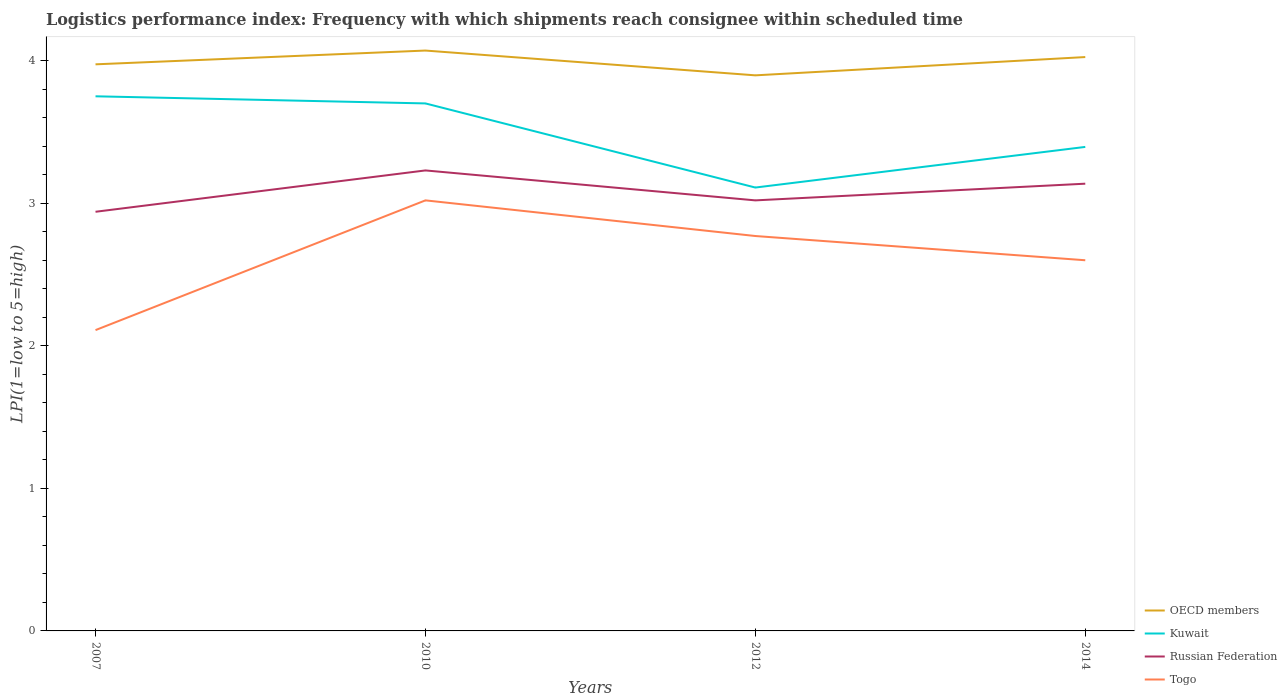How many different coloured lines are there?
Provide a short and direct response. 4. Across all years, what is the maximum logistics performance index in Russian Federation?
Offer a terse response. 2.94. What is the total logistics performance index in Togo in the graph?
Provide a short and direct response. -0.49. What is the difference between the highest and the second highest logistics performance index in OECD members?
Your answer should be very brief. 0.17. Is the logistics performance index in Togo strictly greater than the logistics performance index in Kuwait over the years?
Keep it short and to the point. Yes. How many lines are there?
Provide a succinct answer. 4. Where does the legend appear in the graph?
Offer a terse response. Bottom right. How many legend labels are there?
Give a very brief answer. 4. What is the title of the graph?
Your answer should be compact. Logistics performance index: Frequency with which shipments reach consignee within scheduled time. Does "Bhutan" appear as one of the legend labels in the graph?
Provide a short and direct response. No. What is the label or title of the X-axis?
Give a very brief answer. Years. What is the label or title of the Y-axis?
Offer a very short reply. LPI(1=low to 5=high). What is the LPI(1=low to 5=high) in OECD members in 2007?
Make the answer very short. 3.97. What is the LPI(1=low to 5=high) of Kuwait in 2007?
Offer a terse response. 3.75. What is the LPI(1=low to 5=high) in Russian Federation in 2007?
Keep it short and to the point. 2.94. What is the LPI(1=low to 5=high) in Togo in 2007?
Ensure brevity in your answer.  2.11. What is the LPI(1=low to 5=high) in OECD members in 2010?
Your answer should be very brief. 4.07. What is the LPI(1=low to 5=high) of Russian Federation in 2010?
Provide a short and direct response. 3.23. What is the LPI(1=low to 5=high) of Togo in 2010?
Ensure brevity in your answer.  3.02. What is the LPI(1=low to 5=high) of OECD members in 2012?
Keep it short and to the point. 3.9. What is the LPI(1=low to 5=high) in Kuwait in 2012?
Make the answer very short. 3.11. What is the LPI(1=low to 5=high) of Russian Federation in 2012?
Provide a short and direct response. 3.02. What is the LPI(1=low to 5=high) in Togo in 2012?
Offer a very short reply. 2.77. What is the LPI(1=low to 5=high) of OECD members in 2014?
Your answer should be compact. 4.03. What is the LPI(1=low to 5=high) in Kuwait in 2014?
Offer a terse response. 3.39. What is the LPI(1=low to 5=high) in Russian Federation in 2014?
Your answer should be very brief. 3.14. What is the LPI(1=low to 5=high) in Togo in 2014?
Ensure brevity in your answer.  2.6. Across all years, what is the maximum LPI(1=low to 5=high) in OECD members?
Offer a terse response. 4.07. Across all years, what is the maximum LPI(1=low to 5=high) of Kuwait?
Your answer should be compact. 3.75. Across all years, what is the maximum LPI(1=low to 5=high) of Russian Federation?
Your response must be concise. 3.23. Across all years, what is the maximum LPI(1=low to 5=high) in Togo?
Your answer should be very brief. 3.02. Across all years, what is the minimum LPI(1=low to 5=high) of OECD members?
Your answer should be compact. 3.9. Across all years, what is the minimum LPI(1=low to 5=high) in Kuwait?
Offer a very short reply. 3.11. Across all years, what is the minimum LPI(1=low to 5=high) of Russian Federation?
Provide a short and direct response. 2.94. Across all years, what is the minimum LPI(1=low to 5=high) of Togo?
Make the answer very short. 2.11. What is the total LPI(1=low to 5=high) in OECD members in the graph?
Your answer should be very brief. 15.97. What is the total LPI(1=low to 5=high) of Kuwait in the graph?
Your response must be concise. 13.96. What is the total LPI(1=low to 5=high) in Russian Federation in the graph?
Provide a short and direct response. 12.33. What is the difference between the LPI(1=low to 5=high) in OECD members in 2007 and that in 2010?
Ensure brevity in your answer.  -0.1. What is the difference between the LPI(1=low to 5=high) of Kuwait in 2007 and that in 2010?
Provide a short and direct response. 0.05. What is the difference between the LPI(1=low to 5=high) of Russian Federation in 2007 and that in 2010?
Your response must be concise. -0.29. What is the difference between the LPI(1=low to 5=high) in Togo in 2007 and that in 2010?
Your answer should be compact. -0.91. What is the difference between the LPI(1=low to 5=high) of OECD members in 2007 and that in 2012?
Keep it short and to the point. 0.08. What is the difference between the LPI(1=low to 5=high) of Kuwait in 2007 and that in 2012?
Offer a very short reply. 0.64. What is the difference between the LPI(1=low to 5=high) of Russian Federation in 2007 and that in 2012?
Your response must be concise. -0.08. What is the difference between the LPI(1=low to 5=high) of Togo in 2007 and that in 2012?
Offer a very short reply. -0.66. What is the difference between the LPI(1=low to 5=high) of OECD members in 2007 and that in 2014?
Offer a terse response. -0.05. What is the difference between the LPI(1=low to 5=high) of Kuwait in 2007 and that in 2014?
Keep it short and to the point. 0.35. What is the difference between the LPI(1=low to 5=high) of Russian Federation in 2007 and that in 2014?
Your answer should be very brief. -0.2. What is the difference between the LPI(1=low to 5=high) of Togo in 2007 and that in 2014?
Provide a short and direct response. -0.49. What is the difference between the LPI(1=low to 5=high) in OECD members in 2010 and that in 2012?
Your answer should be compact. 0.17. What is the difference between the LPI(1=low to 5=high) of Kuwait in 2010 and that in 2012?
Give a very brief answer. 0.59. What is the difference between the LPI(1=low to 5=high) in Russian Federation in 2010 and that in 2012?
Your answer should be compact. 0.21. What is the difference between the LPI(1=low to 5=high) of Togo in 2010 and that in 2012?
Offer a terse response. 0.25. What is the difference between the LPI(1=low to 5=high) of OECD members in 2010 and that in 2014?
Offer a terse response. 0.05. What is the difference between the LPI(1=low to 5=high) of Kuwait in 2010 and that in 2014?
Your answer should be compact. 0.3. What is the difference between the LPI(1=low to 5=high) in Russian Federation in 2010 and that in 2014?
Your answer should be compact. 0.09. What is the difference between the LPI(1=low to 5=high) of Togo in 2010 and that in 2014?
Give a very brief answer. 0.42. What is the difference between the LPI(1=low to 5=high) of OECD members in 2012 and that in 2014?
Your answer should be very brief. -0.13. What is the difference between the LPI(1=low to 5=high) of Kuwait in 2012 and that in 2014?
Make the answer very short. -0.28. What is the difference between the LPI(1=low to 5=high) in Russian Federation in 2012 and that in 2014?
Give a very brief answer. -0.12. What is the difference between the LPI(1=low to 5=high) of Togo in 2012 and that in 2014?
Provide a succinct answer. 0.17. What is the difference between the LPI(1=low to 5=high) of OECD members in 2007 and the LPI(1=low to 5=high) of Kuwait in 2010?
Give a very brief answer. 0.27. What is the difference between the LPI(1=low to 5=high) of OECD members in 2007 and the LPI(1=low to 5=high) of Russian Federation in 2010?
Offer a terse response. 0.74. What is the difference between the LPI(1=low to 5=high) of OECD members in 2007 and the LPI(1=low to 5=high) of Togo in 2010?
Your answer should be very brief. 0.95. What is the difference between the LPI(1=low to 5=high) of Kuwait in 2007 and the LPI(1=low to 5=high) of Russian Federation in 2010?
Ensure brevity in your answer.  0.52. What is the difference between the LPI(1=low to 5=high) in Kuwait in 2007 and the LPI(1=low to 5=high) in Togo in 2010?
Your response must be concise. 0.73. What is the difference between the LPI(1=low to 5=high) of Russian Federation in 2007 and the LPI(1=low to 5=high) of Togo in 2010?
Your answer should be very brief. -0.08. What is the difference between the LPI(1=low to 5=high) of OECD members in 2007 and the LPI(1=low to 5=high) of Kuwait in 2012?
Offer a very short reply. 0.86. What is the difference between the LPI(1=low to 5=high) in OECD members in 2007 and the LPI(1=low to 5=high) in Russian Federation in 2012?
Give a very brief answer. 0.95. What is the difference between the LPI(1=low to 5=high) of OECD members in 2007 and the LPI(1=low to 5=high) of Togo in 2012?
Offer a very short reply. 1.2. What is the difference between the LPI(1=low to 5=high) of Kuwait in 2007 and the LPI(1=low to 5=high) of Russian Federation in 2012?
Offer a terse response. 0.73. What is the difference between the LPI(1=low to 5=high) of Kuwait in 2007 and the LPI(1=low to 5=high) of Togo in 2012?
Provide a short and direct response. 0.98. What is the difference between the LPI(1=low to 5=high) of Russian Federation in 2007 and the LPI(1=low to 5=high) of Togo in 2012?
Your response must be concise. 0.17. What is the difference between the LPI(1=low to 5=high) of OECD members in 2007 and the LPI(1=low to 5=high) of Kuwait in 2014?
Your response must be concise. 0.58. What is the difference between the LPI(1=low to 5=high) of OECD members in 2007 and the LPI(1=low to 5=high) of Russian Federation in 2014?
Your answer should be very brief. 0.84. What is the difference between the LPI(1=low to 5=high) of OECD members in 2007 and the LPI(1=low to 5=high) of Togo in 2014?
Provide a succinct answer. 1.37. What is the difference between the LPI(1=low to 5=high) of Kuwait in 2007 and the LPI(1=low to 5=high) of Russian Federation in 2014?
Ensure brevity in your answer.  0.61. What is the difference between the LPI(1=low to 5=high) in Kuwait in 2007 and the LPI(1=low to 5=high) in Togo in 2014?
Offer a terse response. 1.15. What is the difference between the LPI(1=low to 5=high) in Russian Federation in 2007 and the LPI(1=low to 5=high) in Togo in 2014?
Provide a succinct answer. 0.34. What is the difference between the LPI(1=low to 5=high) in OECD members in 2010 and the LPI(1=low to 5=high) in Kuwait in 2012?
Your answer should be very brief. 0.96. What is the difference between the LPI(1=low to 5=high) in OECD members in 2010 and the LPI(1=low to 5=high) in Russian Federation in 2012?
Your answer should be very brief. 1.05. What is the difference between the LPI(1=low to 5=high) in OECD members in 2010 and the LPI(1=low to 5=high) in Togo in 2012?
Your response must be concise. 1.3. What is the difference between the LPI(1=low to 5=high) of Kuwait in 2010 and the LPI(1=low to 5=high) of Russian Federation in 2012?
Offer a very short reply. 0.68. What is the difference between the LPI(1=low to 5=high) in Russian Federation in 2010 and the LPI(1=low to 5=high) in Togo in 2012?
Keep it short and to the point. 0.46. What is the difference between the LPI(1=low to 5=high) in OECD members in 2010 and the LPI(1=low to 5=high) in Kuwait in 2014?
Provide a succinct answer. 0.68. What is the difference between the LPI(1=low to 5=high) of OECD members in 2010 and the LPI(1=low to 5=high) of Russian Federation in 2014?
Offer a terse response. 0.93. What is the difference between the LPI(1=low to 5=high) in OECD members in 2010 and the LPI(1=low to 5=high) in Togo in 2014?
Offer a terse response. 1.47. What is the difference between the LPI(1=low to 5=high) in Kuwait in 2010 and the LPI(1=low to 5=high) in Russian Federation in 2014?
Ensure brevity in your answer.  0.56. What is the difference between the LPI(1=low to 5=high) of Russian Federation in 2010 and the LPI(1=low to 5=high) of Togo in 2014?
Ensure brevity in your answer.  0.63. What is the difference between the LPI(1=low to 5=high) of OECD members in 2012 and the LPI(1=low to 5=high) of Kuwait in 2014?
Give a very brief answer. 0.5. What is the difference between the LPI(1=low to 5=high) of OECD members in 2012 and the LPI(1=low to 5=high) of Russian Federation in 2014?
Offer a terse response. 0.76. What is the difference between the LPI(1=low to 5=high) in OECD members in 2012 and the LPI(1=low to 5=high) in Togo in 2014?
Give a very brief answer. 1.3. What is the difference between the LPI(1=low to 5=high) in Kuwait in 2012 and the LPI(1=low to 5=high) in Russian Federation in 2014?
Your response must be concise. -0.03. What is the difference between the LPI(1=low to 5=high) of Kuwait in 2012 and the LPI(1=low to 5=high) of Togo in 2014?
Make the answer very short. 0.51. What is the difference between the LPI(1=low to 5=high) in Russian Federation in 2012 and the LPI(1=low to 5=high) in Togo in 2014?
Your answer should be compact. 0.42. What is the average LPI(1=low to 5=high) in OECD members per year?
Your response must be concise. 3.99. What is the average LPI(1=low to 5=high) in Kuwait per year?
Your response must be concise. 3.49. What is the average LPI(1=low to 5=high) in Russian Federation per year?
Provide a short and direct response. 3.08. What is the average LPI(1=low to 5=high) in Togo per year?
Ensure brevity in your answer.  2.62. In the year 2007, what is the difference between the LPI(1=low to 5=high) in OECD members and LPI(1=low to 5=high) in Kuwait?
Provide a succinct answer. 0.22. In the year 2007, what is the difference between the LPI(1=low to 5=high) in OECD members and LPI(1=low to 5=high) in Russian Federation?
Your response must be concise. 1.03. In the year 2007, what is the difference between the LPI(1=low to 5=high) in OECD members and LPI(1=low to 5=high) in Togo?
Ensure brevity in your answer.  1.86. In the year 2007, what is the difference between the LPI(1=low to 5=high) of Kuwait and LPI(1=low to 5=high) of Russian Federation?
Provide a succinct answer. 0.81. In the year 2007, what is the difference between the LPI(1=low to 5=high) of Kuwait and LPI(1=low to 5=high) of Togo?
Provide a short and direct response. 1.64. In the year 2007, what is the difference between the LPI(1=low to 5=high) of Russian Federation and LPI(1=low to 5=high) of Togo?
Give a very brief answer. 0.83. In the year 2010, what is the difference between the LPI(1=low to 5=high) in OECD members and LPI(1=low to 5=high) in Kuwait?
Make the answer very short. 0.37. In the year 2010, what is the difference between the LPI(1=low to 5=high) in OECD members and LPI(1=low to 5=high) in Russian Federation?
Keep it short and to the point. 0.84. In the year 2010, what is the difference between the LPI(1=low to 5=high) in OECD members and LPI(1=low to 5=high) in Togo?
Your answer should be compact. 1.05. In the year 2010, what is the difference between the LPI(1=low to 5=high) of Kuwait and LPI(1=low to 5=high) of Russian Federation?
Give a very brief answer. 0.47. In the year 2010, what is the difference between the LPI(1=low to 5=high) of Kuwait and LPI(1=low to 5=high) of Togo?
Provide a short and direct response. 0.68. In the year 2010, what is the difference between the LPI(1=low to 5=high) of Russian Federation and LPI(1=low to 5=high) of Togo?
Your answer should be compact. 0.21. In the year 2012, what is the difference between the LPI(1=low to 5=high) in OECD members and LPI(1=low to 5=high) in Kuwait?
Make the answer very short. 0.79. In the year 2012, what is the difference between the LPI(1=low to 5=high) of OECD members and LPI(1=low to 5=high) of Russian Federation?
Give a very brief answer. 0.88. In the year 2012, what is the difference between the LPI(1=low to 5=high) in OECD members and LPI(1=low to 5=high) in Togo?
Your answer should be compact. 1.13. In the year 2012, what is the difference between the LPI(1=low to 5=high) in Kuwait and LPI(1=low to 5=high) in Russian Federation?
Your answer should be compact. 0.09. In the year 2012, what is the difference between the LPI(1=low to 5=high) of Kuwait and LPI(1=low to 5=high) of Togo?
Give a very brief answer. 0.34. In the year 2014, what is the difference between the LPI(1=low to 5=high) in OECD members and LPI(1=low to 5=high) in Kuwait?
Ensure brevity in your answer.  0.63. In the year 2014, what is the difference between the LPI(1=low to 5=high) in OECD members and LPI(1=low to 5=high) in Russian Federation?
Your answer should be compact. 0.89. In the year 2014, what is the difference between the LPI(1=low to 5=high) in OECD members and LPI(1=low to 5=high) in Togo?
Your answer should be compact. 1.43. In the year 2014, what is the difference between the LPI(1=low to 5=high) of Kuwait and LPI(1=low to 5=high) of Russian Federation?
Offer a very short reply. 0.26. In the year 2014, what is the difference between the LPI(1=low to 5=high) in Kuwait and LPI(1=low to 5=high) in Togo?
Your response must be concise. 0.8. In the year 2014, what is the difference between the LPI(1=low to 5=high) in Russian Federation and LPI(1=low to 5=high) in Togo?
Ensure brevity in your answer.  0.54. What is the ratio of the LPI(1=low to 5=high) in OECD members in 2007 to that in 2010?
Offer a terse response. 0.98. What is the ratio of the LPI(1=low to 5=high) in Kuwait in 2007 to that in 2010?
Provide a succinct answer. 1.01. What is the ratio of the LPI(1=low to 5=high) of Russian Federation in 2007 to that in 2010?
Provide a short and direct response. 0.91. What is the ratio of the LPI(1=low to 5=high) of Togo in 2007 to that in 2010?
Provide a short and direct response. 0.7. What is the ratio of the LPI(1=low to 5=high) of OECD members in 2007 to that in 2012?
Offer a terse response. 1.02. What is the ratio of the LPI(1=low to 5=high) of Kuwait in 2007 to that in 2012?
Offer a very short reply. 1.21. What is the ratio of the LPI(1=low to 5=high) of Russian Federation in 2007 to that in 2012?
Keep it short and to the point. 0.97. What is the ratio of the LPI(1=low to 5=high) in Togo in 2007 to that in 2012?
Provide a succinct answer. 0.76. What is the ratio of the LPI(1=low to 5=high) in OECD members in 2007 to that in 2014?
Offer a very short reply. 0.99. What is the ratio of the LPI(1=low to 5=high) of Kuwait in 2007 to that in 2014?
Offer a very short reply. 1.1. What is the ratio of the LPI(1=low to 5=high) in Russian Federation in 2007 to that in 2014?
Provide a short and direct response. 0.94. What is the ratio of the LPI(1=low to 5=high) of Togo in 2007 to that in 2014?
Your answer should be very brief. 0.81. What is the ratio of the LPI(1=low to 5=high) of OECD members in 2010 to that in 2012?
Provide a short and direct response. 1.04. What is the ratio of the LPI(1=low to 5=high) of Kuwait in 2010 to that in 2012?
Provide a succinct answer. 1.19. What is the ratio of the LPI(1=low to 5=high) of Russian Federation in 2010 to that in 2012?
Make the answer very short. 1.07. What is the ratio of the LPI(1=low to 5=high) of Togo in 2010 to that in 2012?
Your response must be concise. 1.09. What is the ratio of the LPI(1=low to 5=high) of OECD members in 2010 to that in 2014?
Offer a very short reply. 1.01. What is the ratio of the LPI(1=low to 5=high) of Kuwait in 2010 to that in 2014?
Offer a very short reply. 1.09. What is the ratio of the LPI(1=low to 5=high) in Russian Federation in 2010 to that in 2014?
Offer a terse response. 1.03. What is the ratio of the LPI(1=low to 5=high) in Togo in 2010 to that in 2014?
Make the answer very short. 1.16. What is the ratio of the LPI(1=low to 5=high) of OECD members in 2012 to that in 2014?
Provide a short and direct response. 0.97. What is the ratio of the LPI(1=low to 5=high) of Kuwait in 2012 to that in 2014?
Your response must be concise. 0.92. What is the ratio of the LPI(1=low to 5=high) of Russian Federation in 2012 to that in 2014?
Keep it short and to the point. 0.96. What is the ratio of the LPI(1=low to 5=high) of Togo in 2012 to that in 2014?
Your response must be concise. 1.07. What is the difference between the highest and the second highest LPI(1=low to 5=high) of OECD members?
Provide a succinct answer. 0.05. What is the difference between the highest and the second highest LPI(1=low to 5=high) in Kuwait?
Provide a succinct answer. 0.05. What is the difference between the highest and the second highest LPI(1=low to 5=high) of Russian Federation?
Keep it short and to the point. 0.09. What is the difference between the highest and the second highest LPI(1=low to 5=high) in Togo?
Your answer should be very brief. 0.25. What is the difference between the highest and the lowest LPI(1=low to 5=high) in OECD members?
Provide a succinct answer. 0.17. What is the difference between the highest and the lowest LPI(1=low to 5=high) in Kuwait?
Keep it short and to the point. 0.64. What is the difference between the highest and the lowest LPI(1=low to 5=high) in Russian Federation?
Your response must be concise. 0.29. What is the difference between the highest and the lowest LPI(1=low to 5=high) in Togo?
Provide a succinct answer. 0.91. 